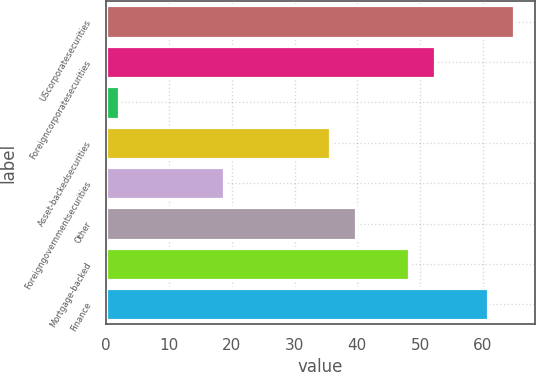Convert chart to OTSL. <chart><loc_0><loc_0><loc_500><loc_500><bar_chart><fcel>UScorporatesecurities<fcel>Foreigncorporatesecurities<fcel>Unnamed: 2<fcel>Asset-backedsecurities<fcel>Foreigngovernmentsecurities<fcel>Other<fcel>Mortgage-backed<fcel>Finance<nl><fcel>65<fcel>52.4<fcel>2<fcel>35.6<fcel>18.8<fcel>39.8<fcel>48.2<fcel>60.8<nl></chart> 